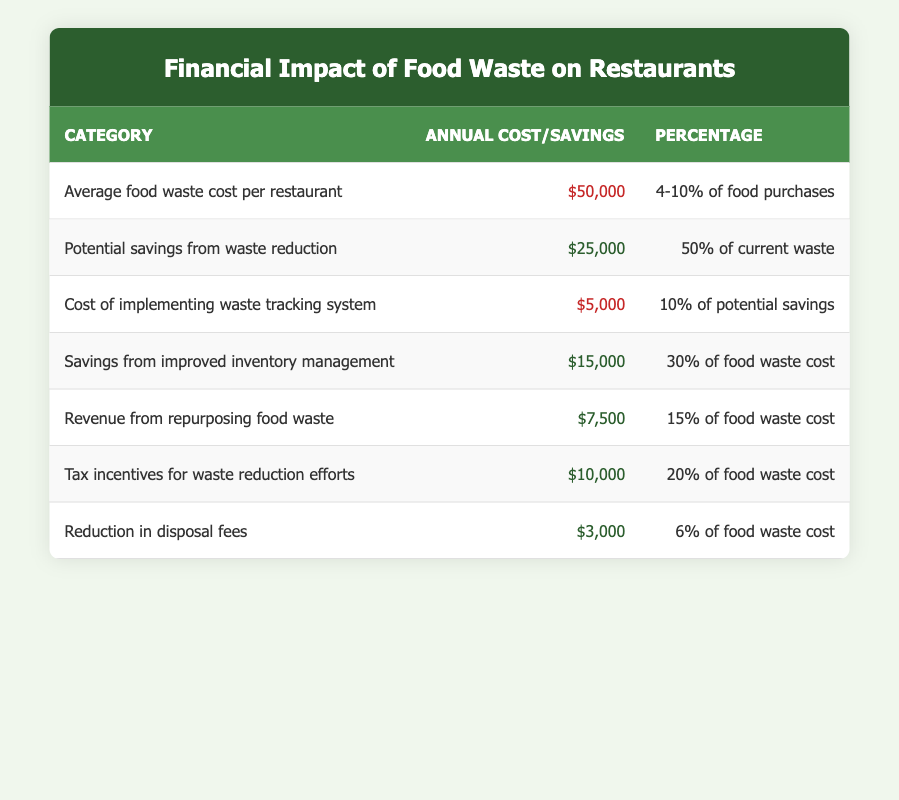What is the average food waste cost per restaurant? The table states that the average food waste cost per restaurant is listed as $50,000. There are no additional calculations needed.
Answer: $50,000 What is the potential savings from waste reduction? The potential savings from waste reduction is explicitly stated as $25,000 in the table, requiring no further breakdown.
Answer: $25,000 How much is spent on implementing a waste tracking system? According to the table, the cost of implementing a waste tracking system is $5,000. This figure is directly taken from the table.
Answer: $5,000 What is the total potential savings and revenue from improved inventory management and tax incentives? The savings from improved inventory management is $15,000 and the revenue from tax incentives is $10,000. Adding these together (15,000 + 10,000) gives a total potential savings and revenue of $25,000.
Answer: $25,000 Is the cost of implementing a waste tracking system greater than the revenue from repurposing food waste? The cost of implementing a waste tracking system is $5,000 while the revenue from repurposing food waste is $7,500. Since $5,000 is less than $7,500, the statement is false.
Answer: No Are the cost savings from improved inventory management and the revenue from tax incentives equal? The savings from improved inventory management is $15,000 and the revenue from tax incentives is $10,000. Since 15,000 does not equal 10,000, the answer to the question is no.
Answer: No What percentage of food purchases does the average food waste cost represent? The average food waste cost is said to be 4-10% of food purchases. This percentage range is listed directly in the table under the relevant category.
Answer: 4-10% What is the difference between potential savings from waste reduction and the cost of implementing a waste tracking system? Potential savings from waste reduction are $25,000 while the cost of the tracking system is $5,000. The difference is calculated as 25,000 - 5,000 = 20,000.
Answer: $20,000 What percentage does the reduction in disposal fees represent compared to food waste cost? The reduction in disposal fees is stated as 6% of the food waste cost in the table, providing a direct percentage reference.
Answer: 6% 